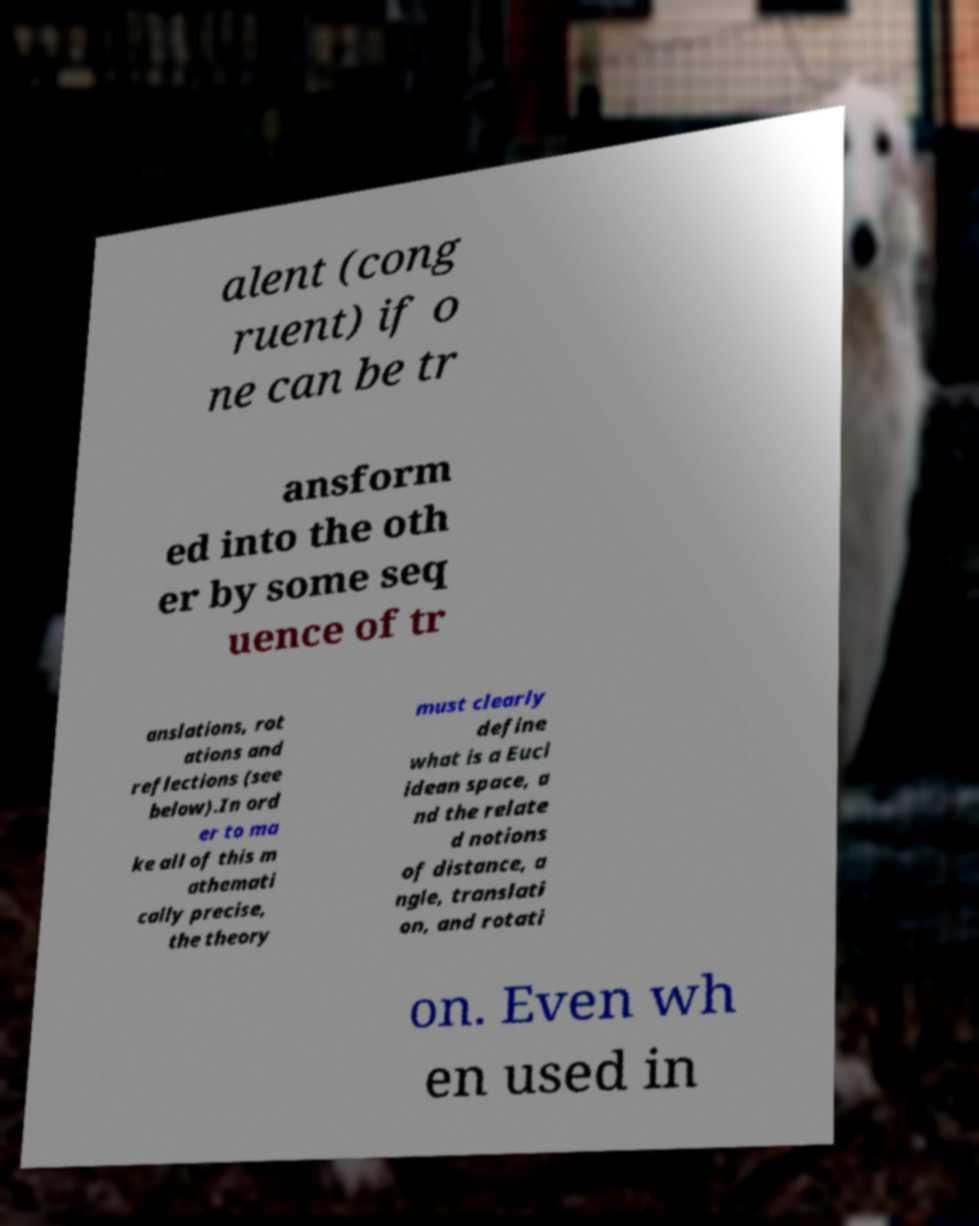Could you assist in decoding the text presented in this image and type it out clearly? alent (cong ruent) if o ne can be tr ansform ed into the oth er by some seq uence of tr anslations, rot ations and reflections (see below).In ord er to ma ke all of this m athemati cally precise, the theory must clearly define what is a Eucl idean space, a nd the relate d notions of distance, a ngle, translati on, and rotati on. Even wh en used in 